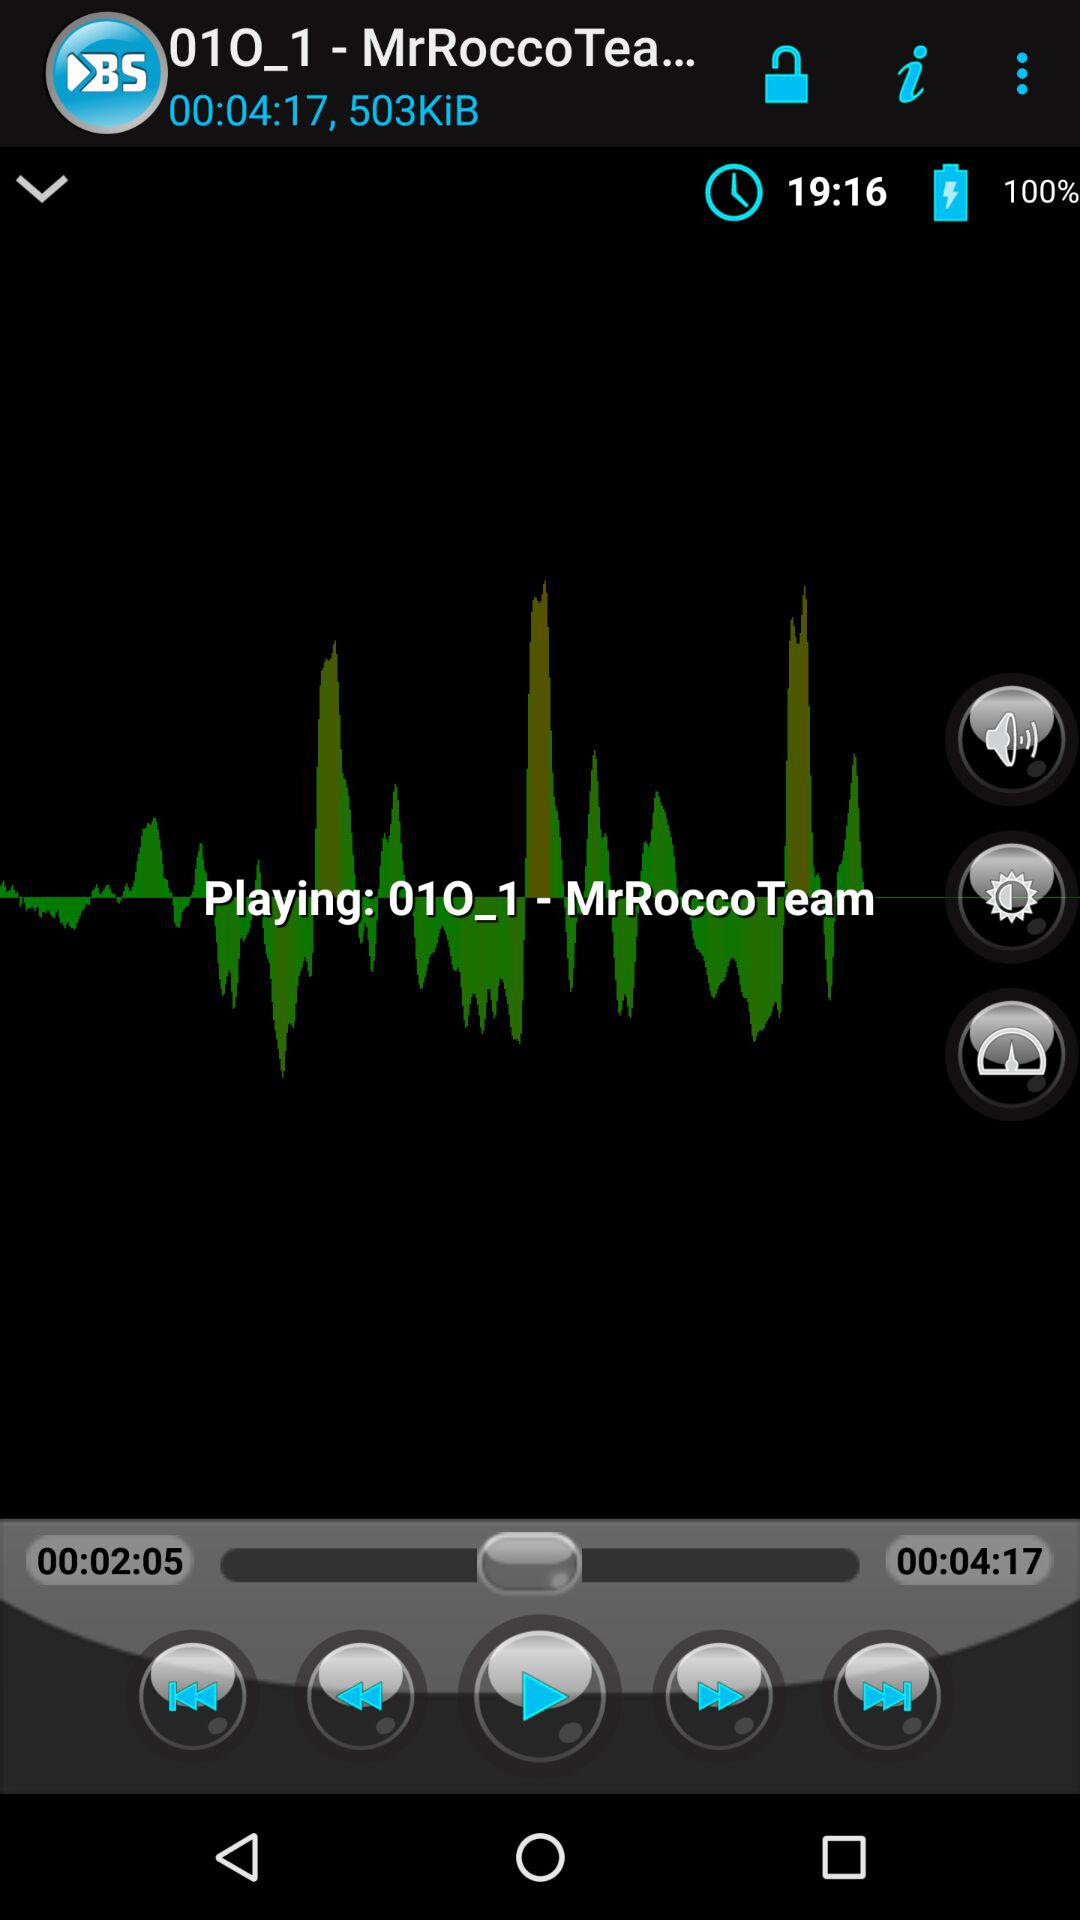What is the version of this application?
When the provided information is insufficient, respond with <no answer>. <no answer> 